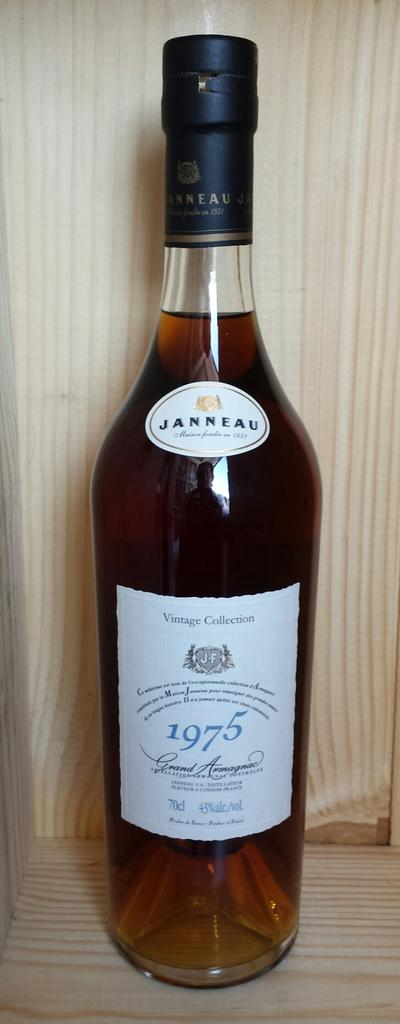What object can be seen in the image with a black lid? There is a bottle in the image with a black lid. What year is mentioned on the label of the bottle? The label on the bottle has the text "1975" on it. Where is the bottle located in the image? The bottle is placed on a table. Can you see any clams near the faucet in the image? There are no clams or faucets present in the image; it only features a bottle with a black lid and a label. 